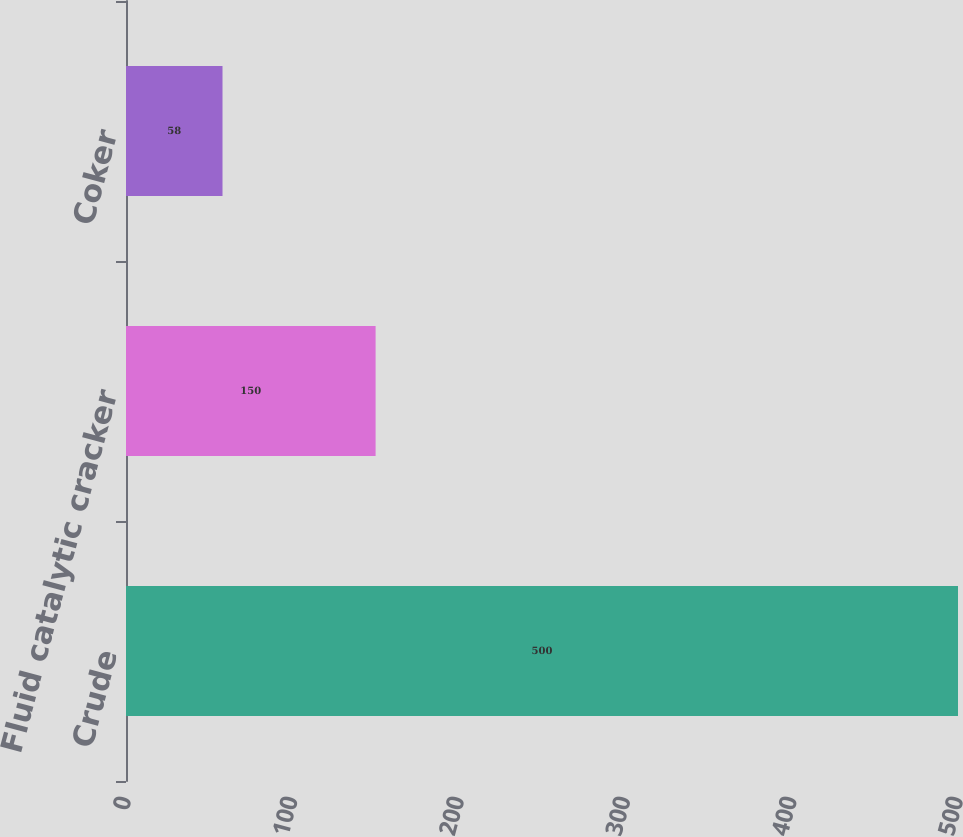Convert chart. <chart><loc_0><loc_0><loc_500><loc_500><bar_chart><fcel>Crude<fcel>Fluid catalytic cracker<fcel>Coker<nl><fcel>500<fcel>150<fcel>58<nl></chart> 